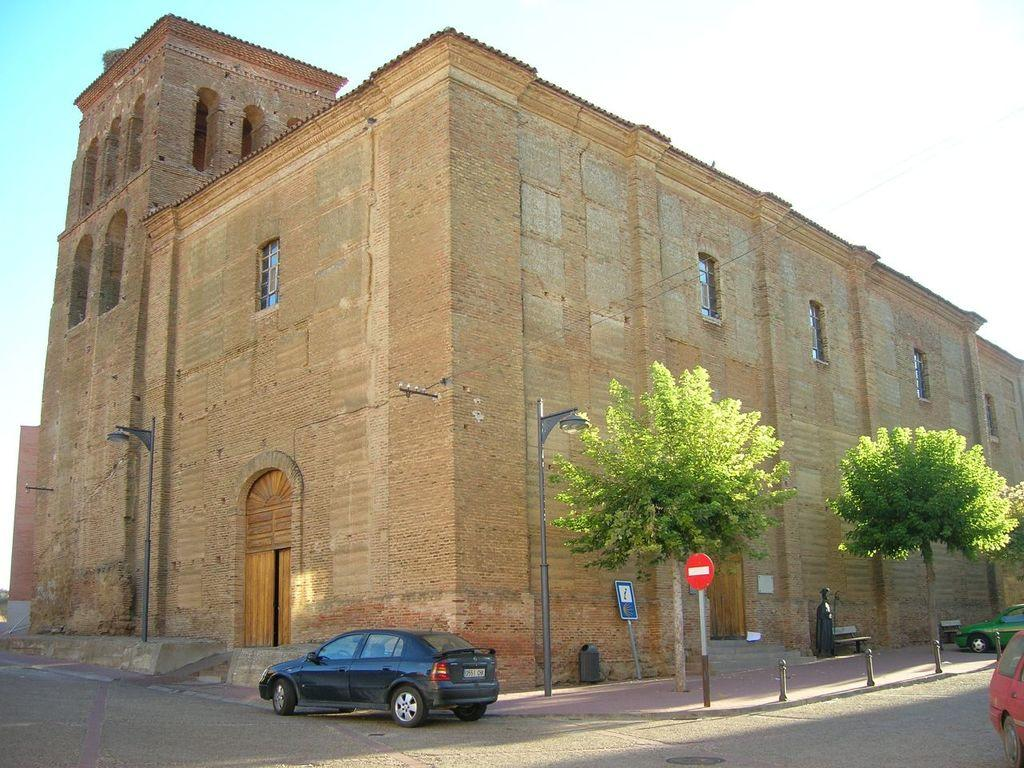What is the main feature of the image? There is a road in the image. What else can be seen on the road? There are vehicles in the image. What structures are present alongside the road? There are poles, boards, and a building in the image. Are there any illumination sources in the image? Yes, there are lights in the image. What type of vegetation is visible in the image? There are trees in the image. Is there any artwork present in the image? Yes, there is a sculpture in the image. What can be seen in the background of the image? The sky is visible in the background of the image. What type of calculator is being used by the tree in the image? There is no calculator present in the image, and trees do not use calculators. 